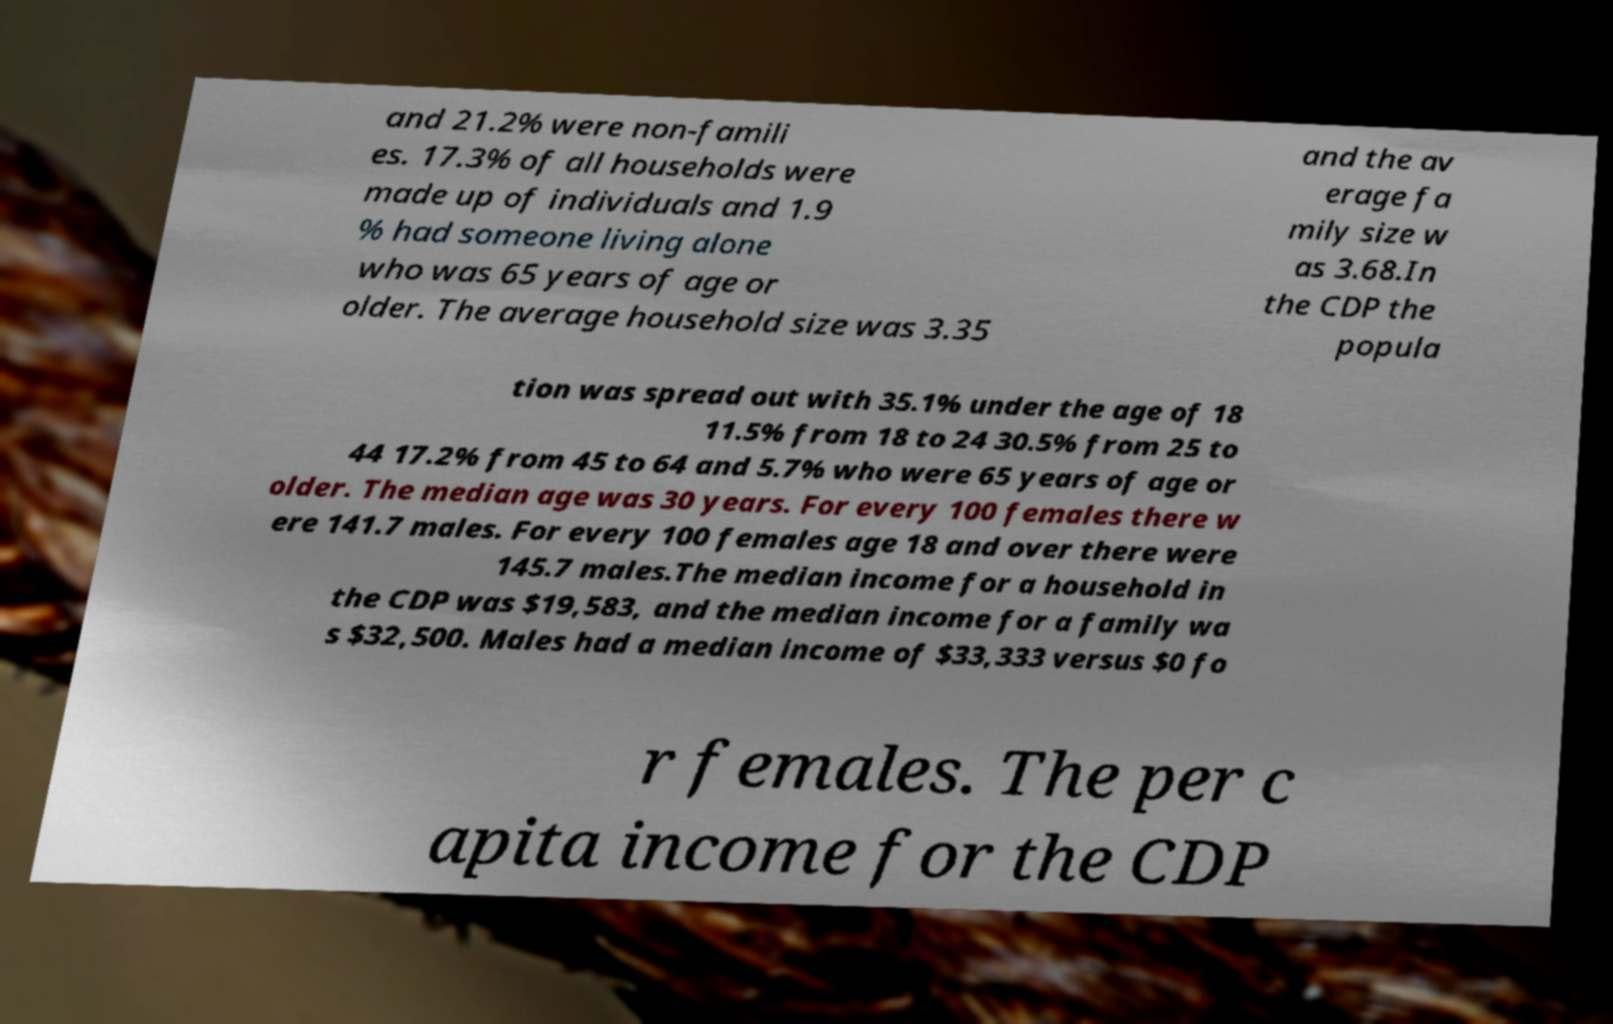Can you read and provide the text displayed in the image?This photo seems to have some interesting text. Can you extract and type it out for me? and 21.2% were non-famili es. 17.3% of all households were made up of individuals and 1.9 % had someone living alone who was 65 years of age or older. The average household size was 3.35 and the av erage fa mily size w as 3.68.In the CDP the popula tion was spread out with 35.1% under the age of 18 11.5% from 18 to 24 30.5% from 25 to 44 17.2% from 45 to 64 and 5.7% who were 65 years of age or older. The median age was 30 years. For every 100 females there w ere 141.7 males. For every 100 females age 18 and over there were 145.7 males.The median income for a household in the CDP was $19,583, and the median income for a family wa s $32,500. Males had a median income of $33,333 versus $0 fo r females. The per c apita income for the CDP 